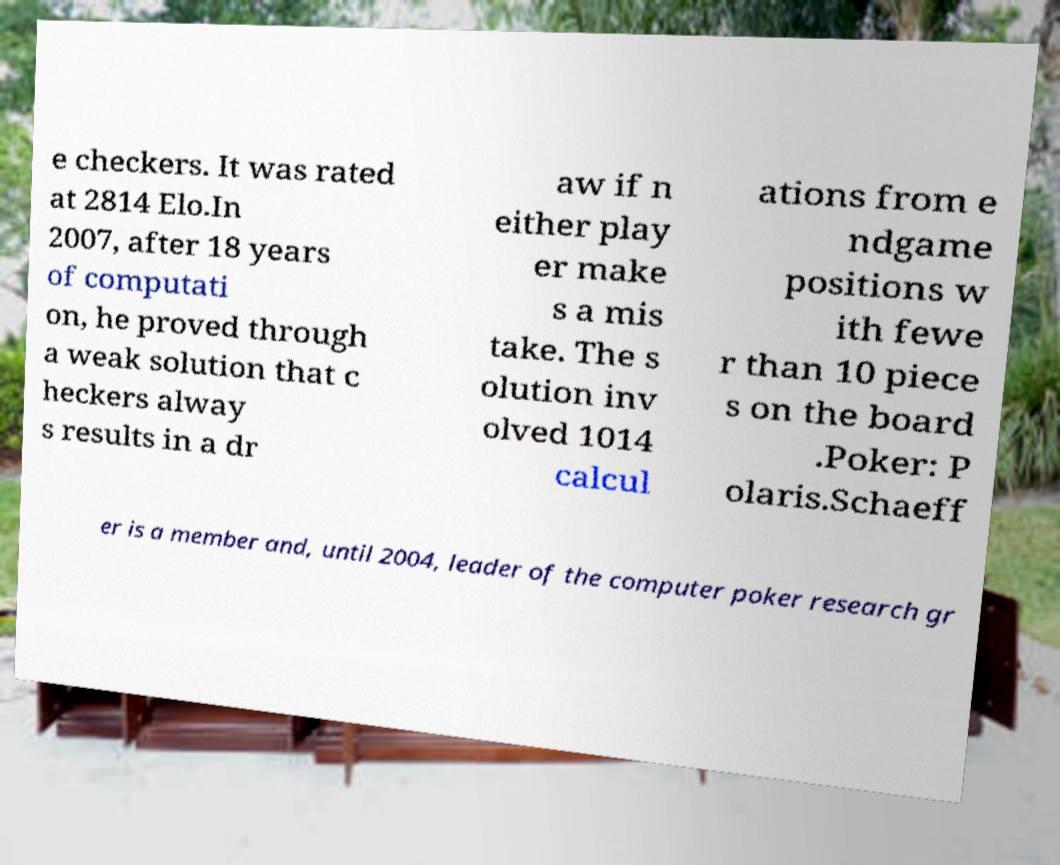Please identify and transcribe the text found in this image. e checkers. It was rated at 2814 Elo.In 2007, after 18 years of computati on, he proved through a weak solution that c heckers alway s results in a dr aw if n either play er make s a mis take. The s olution inv olved 1014 calcul ations from e ndgame positions w ith fewe r than 10 piece s on the board .Poker: P olaris.Schaeff er is a member and, until 2004, leader of the computer poker research gr 